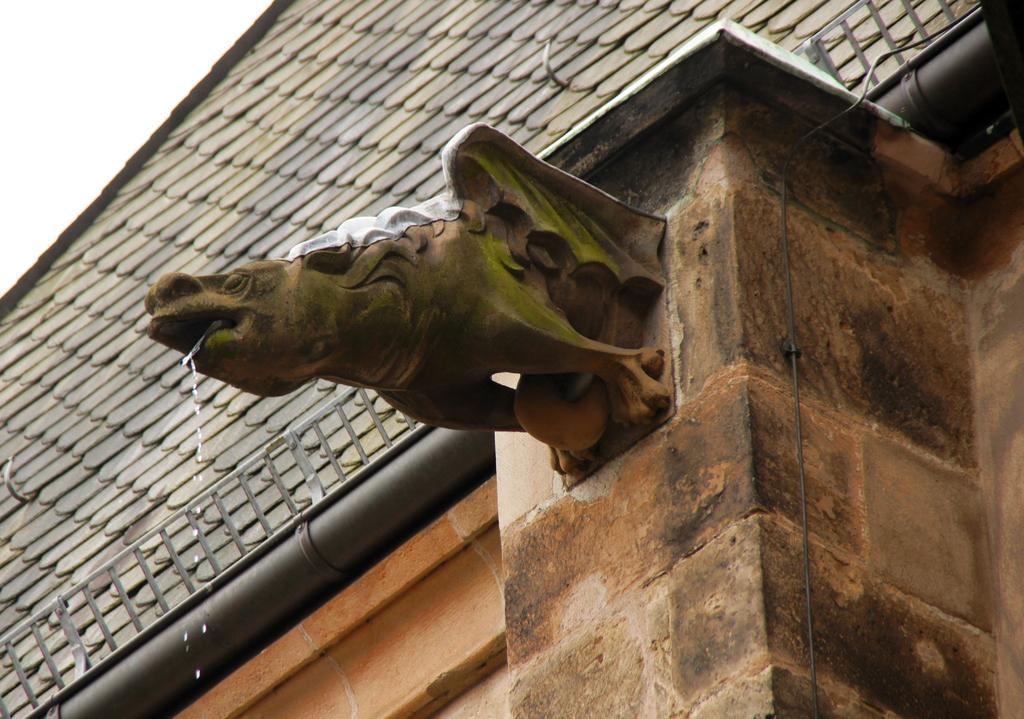How would you summarize this image in a sentence or two? In this image I can see a part of a building. In the middle of the image there is a sculpture of an animal which is attached to the pillar and there is a metal rod. At the top, I can see the roof. In the top left-hand corner, I can see the sky. 